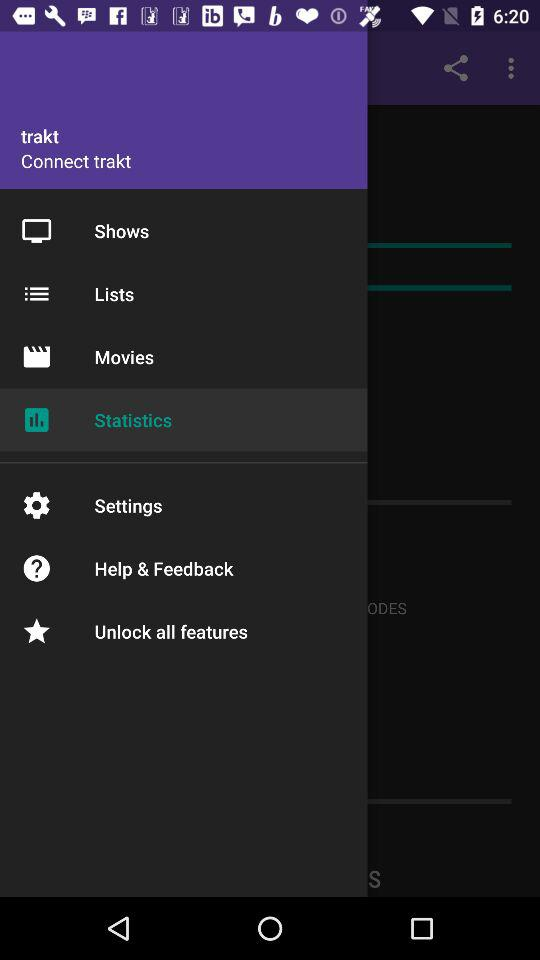What's the user name? The user name is trakt. 